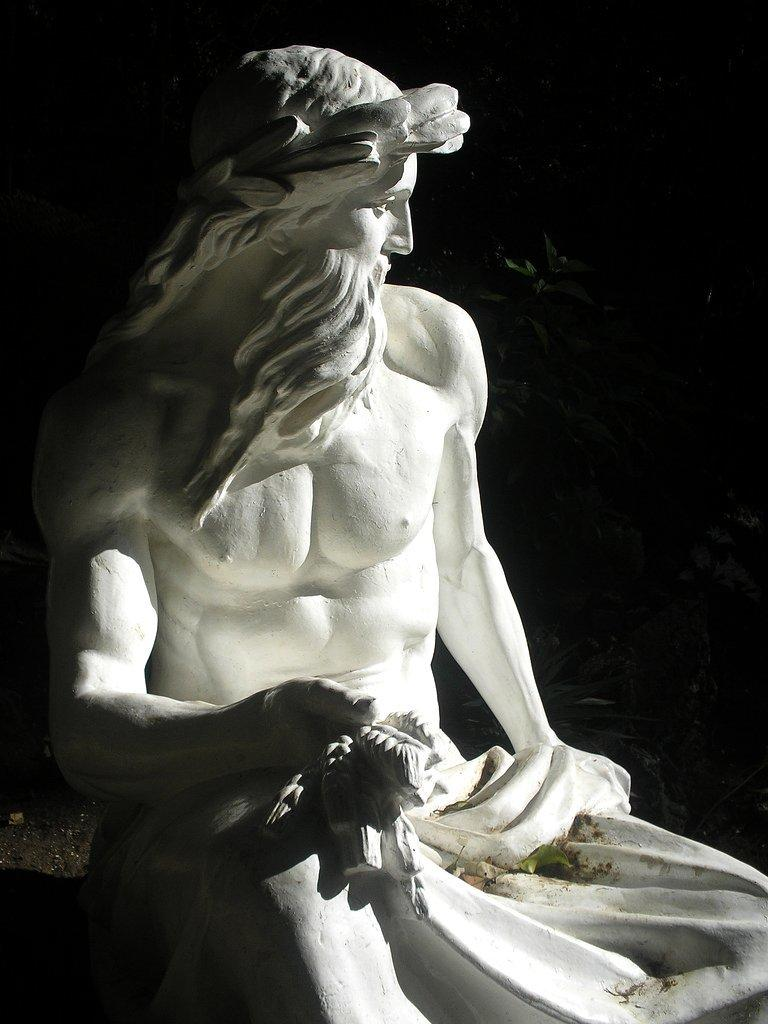What is the general color scheme of the image? The background of the image is dark. What can be seen in the foreground of the image? There is a statue of a man in the image. Is there a car being attacked by a wild animal in the image? No, there is no car or wild animal present in the image. 